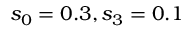Convert formula to latex. <formula><loc_0><loc_0><loc_500><loc_500>s _ { 0 } = 0 . 3 , s _ { 3 } = 0 . 1</formula> 